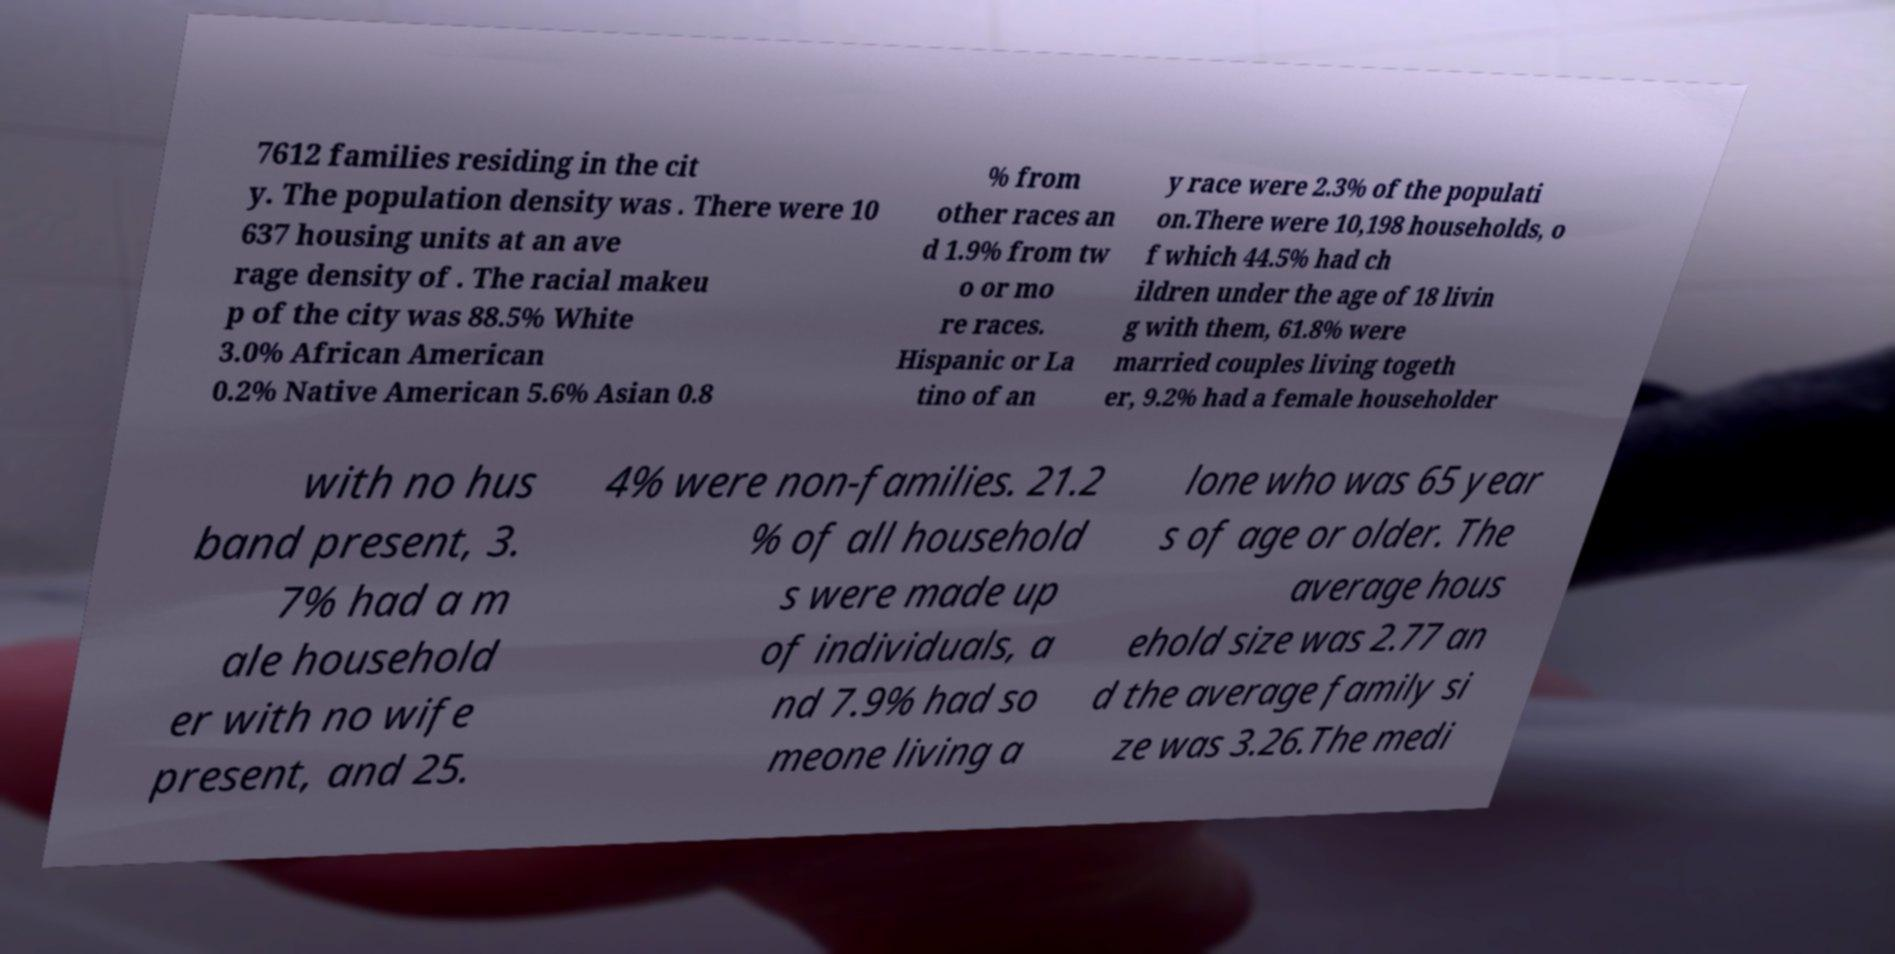I need the written content from this picture converted into text. Can you do that? 7612 families residing in the cit y. The population density was . There were 10 637 housing units at an ave rage density of . The racial makeu p of the city was 88.5% White 3.0% African American 0.2% Native American 5.6% Asian 0.8 % from other races an d 1.9% from tw o or mo re races. Hispanic or La tino of an y race were 2.3% of the populati on.There were 10,198 households, o f which 44.5% had ch ildren under the age of 18 livin g with them, 61.8% were married couples living togeth er, 9.2% had a female householder with no hus band present, 3. 7% had a m ale household er with no wife present, and 25. 4% were non-families. 21.2 % of all household s were made up of individuals, a nd 7.9% had so meone living a lone who was 65 year s of age or older. The average hous ehold size was 2.77 an d the average family si ze was 3.26.The medi 